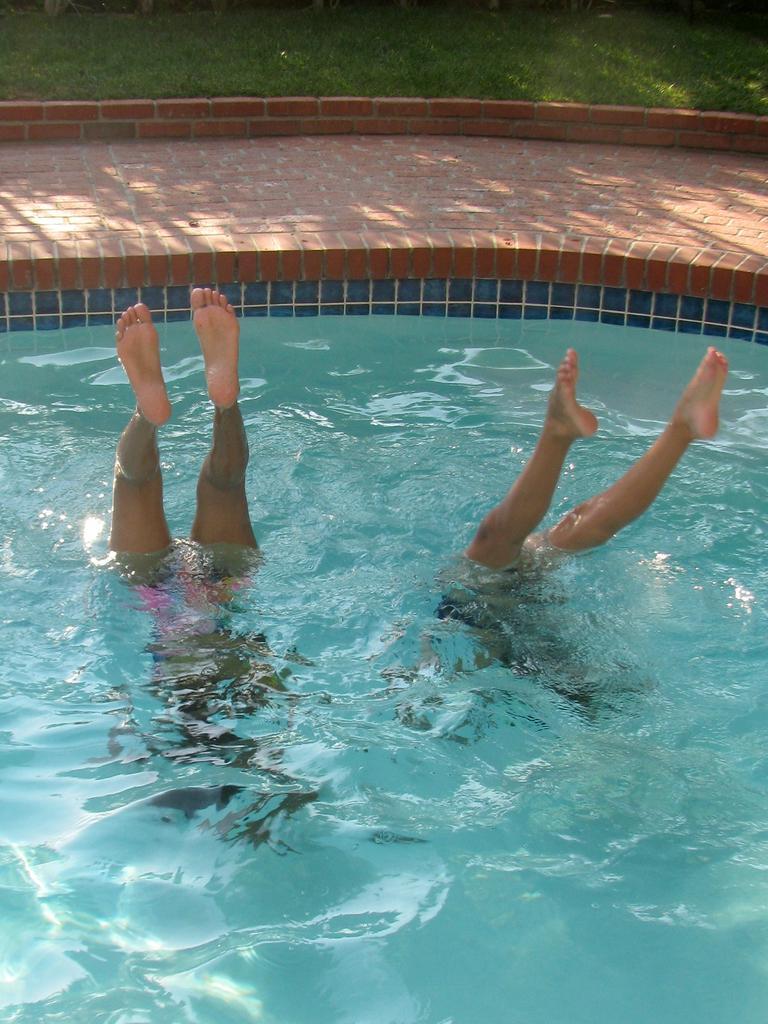Can you describe this image briefly? In the image we can see there are people swimming in the swimming pool and behind there is grass on the ground. 